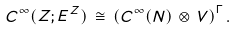Convert formula to latex. <formula><loc_0><loc_0><loc_500><loc_500>C ^ { \infty } ( Z ; E ^ { Z } ) \, \cong \, \left ( C ^ { \infty } ( N ) \, \otimes \, V \right ) ^ { \Gamma } .</formula> 